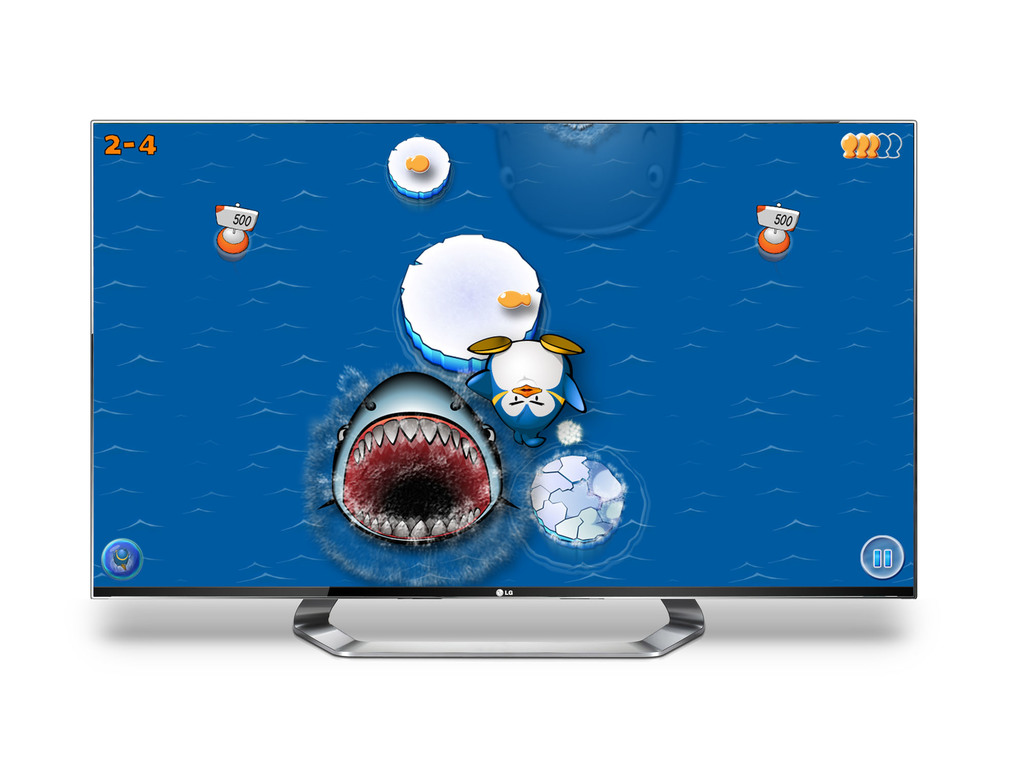What might be the objective of this game based on the visuals? Based on the visuals, the objective of the game appears to involve navigating a series of oceanic stages, collecting scores, and possibly evading or confronting animated sea creatures like the large shark. 